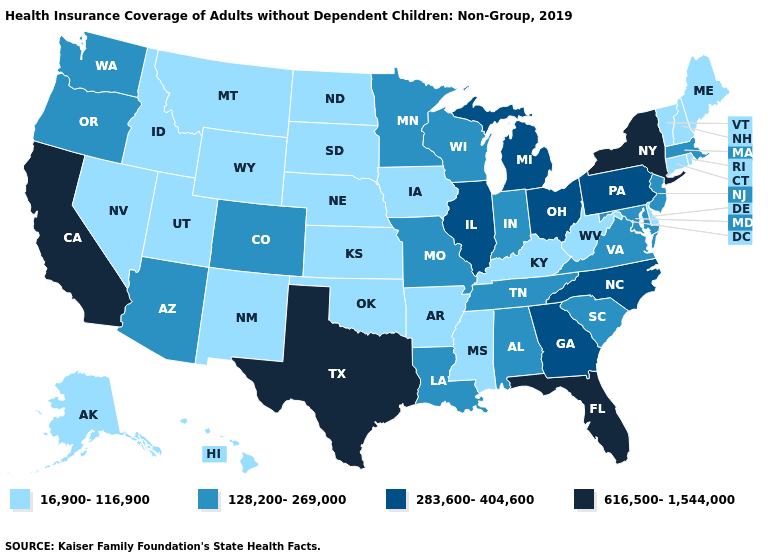Among the states that border Louisiana , does Mississippi have the highest value?
Keep it brief. No. Does Michigan have the highest value in the MidWest?
Answer briefly. Yes. What is the highest value in states that border Alabama?
Quick response, please. 616,500-1,544,000. Among the states that border Tennessee , does Alabama have the lowest value?
Write a very short answer. No. Does Rhode Island have the same value as Kansas?
Give a very brief answer. Yes. What is the highest value in states that border Virginia?
Write a very short answer. 283,600-404,600. Among the states that border Montana , which have the lowest value?
Give a very brief answer. Idaho, North Dakota, South Dakota, Wyoming. Name the states that have a value in the range 283,600-404,600?
Keep it brief. Georgia, Illinois, Michigan, North Carolina, Ohio, Pennsylvania. What is the lowest value in states that border Oregon?
Quick response, please. 16,900-116,900. Which states have the lowest value in the USA?
Short answer required. Alaska, Arkansas, Connecticut, Delaware, Hawaii, Idaho, Iowa, Kansas, Kentucky, Maine, Mississippi, Montana, Nebraska, Nevada, New Hampshire, New Mexico, North Dakota, Oklahoma, Rhode Island, South Dakota, Utah, Vermont, West Virginia, Wyoming. Which states have the lowest value in the USA?
Keep it brief. Alaska, Arkansas, Connecticut, Delaware, Hawaii, Idaho, Iowa, Kansas, Kentucky, Maine, Mississippi, Montana, Nebraska, Nevada, New Hampshire, New Mexico, North Dakota, Oklahoma, Rhode Island, South Dakota, Utah, Vermont, West Virginia, Wyoming. What is the value of Connecticut?
Keep it brief. 16,900-116,900. Does Vermont have the lowest value in the Northeast?
Be succinct. Yes. What is the lowest value in the South?
Give a very brief answer. 16,900-116,900. 